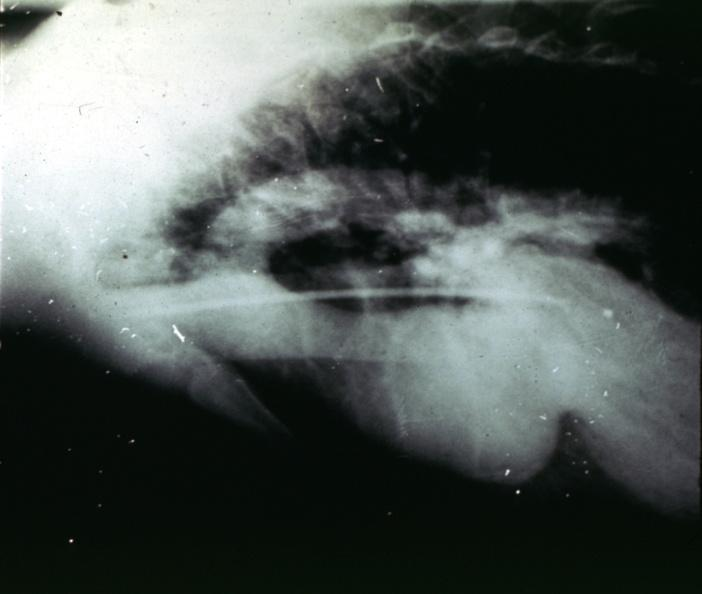does newborn cord around neck show marfans syndrome?
Answer the question using a single word or phrase. No 